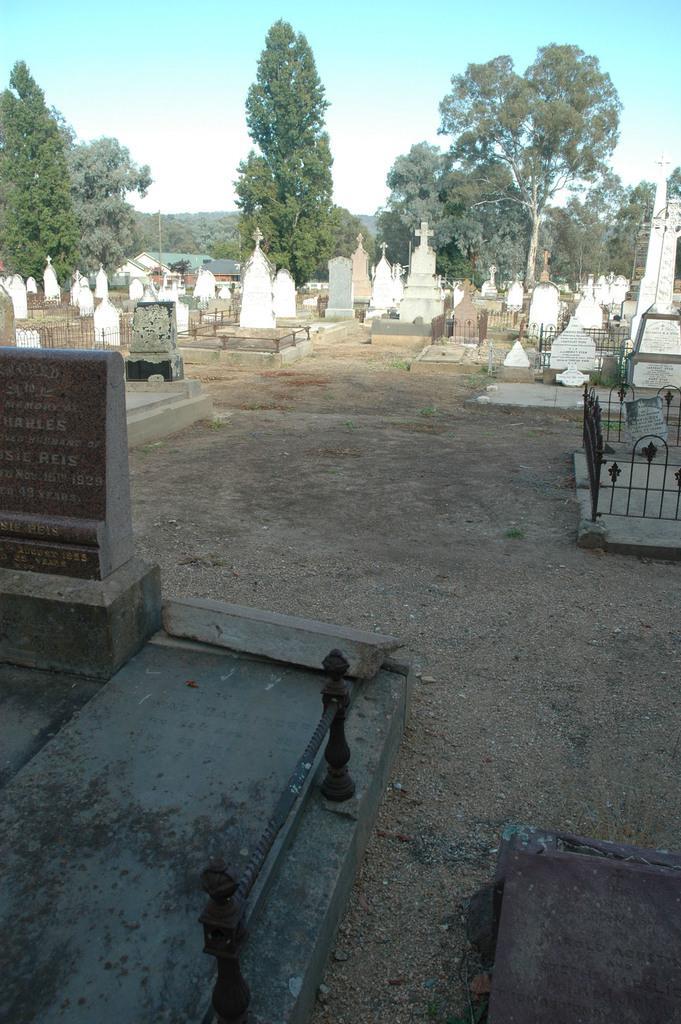Describe this image in one or two sentences. In this image we can see the graveyard, metal barricades, cross. In the background, we can see a group of trees and the sky. 